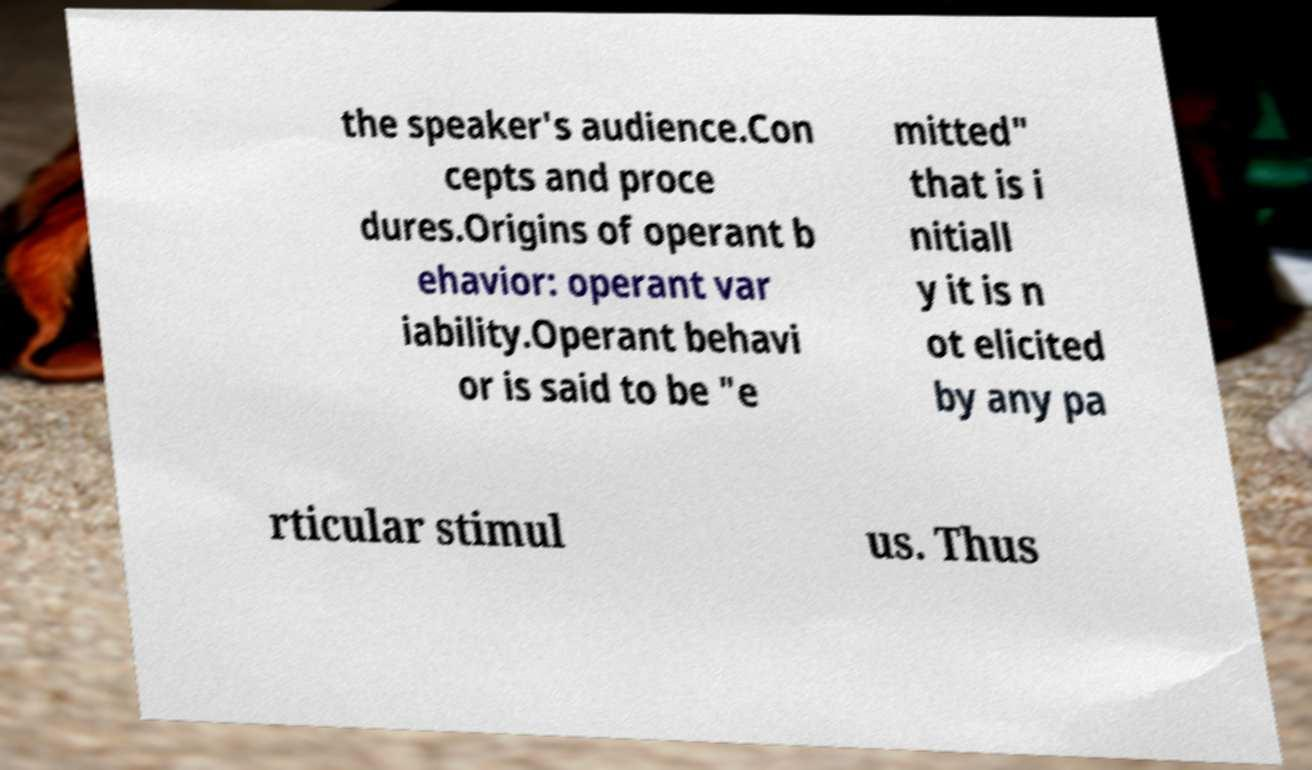Please read and relay the text visible in this image. What does it say? the speaker's audience.Con cepts and proce dures.Origins of operant b ehavior: operant var iability.Operant behavi or is said to be "e mitted" that is i nitiall y it is n ot elicited by any pa rticular stimul us. Thus 